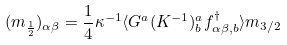<formula> <loc_0><loc_0><loc_500><loc_500>( m _ { \frac { 1 } { 2 } } ) _ { \alpha \beta } = \frac { 1 } { 4 } \kappa ^ { - 1 } \langle G ^ { a } ( K ^ { - 1 } ) ^ { a } _ { b } f _ { \alpha \beta , b } ^ { \dag } \rangle m _ { 3 / 2 }</formula> 